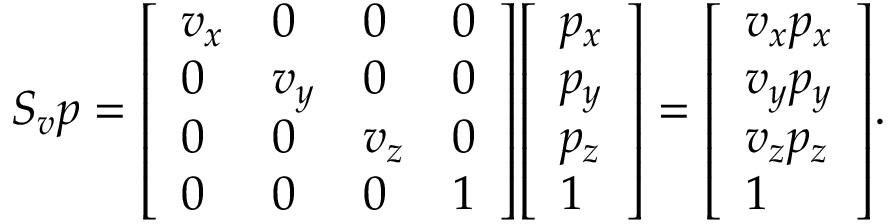<formula> <loc_0><loc_0><loc_500><loc_500>S _ { v } p = { \left [ \begin{array} { l l l l } { v _ { x } } & { 0 } & { 0 } & { 0 } \\ { 0 } & { v _ { y } } & { 0 } & { 0 } \\ { 0 } & { 0 } & { v _ { z } } & { 0 } \\ { 0 } & { 0 } & { 0 } & { 1 } \end{array} \right ] } { \left [ \begin{array} { l } { p _ { x } } \\ { p _ { y } } \\ { p _ { z } } \\ { 1 } \end{array} \right ] } = { \left [ \begin{array} { l } { v _ { x } p _ { x } } \\ { v _ { y } p _ { y } } \\ { v _ { z } p _ { z } } \\ { 1 } \end{array} \right ] } .</formula> 